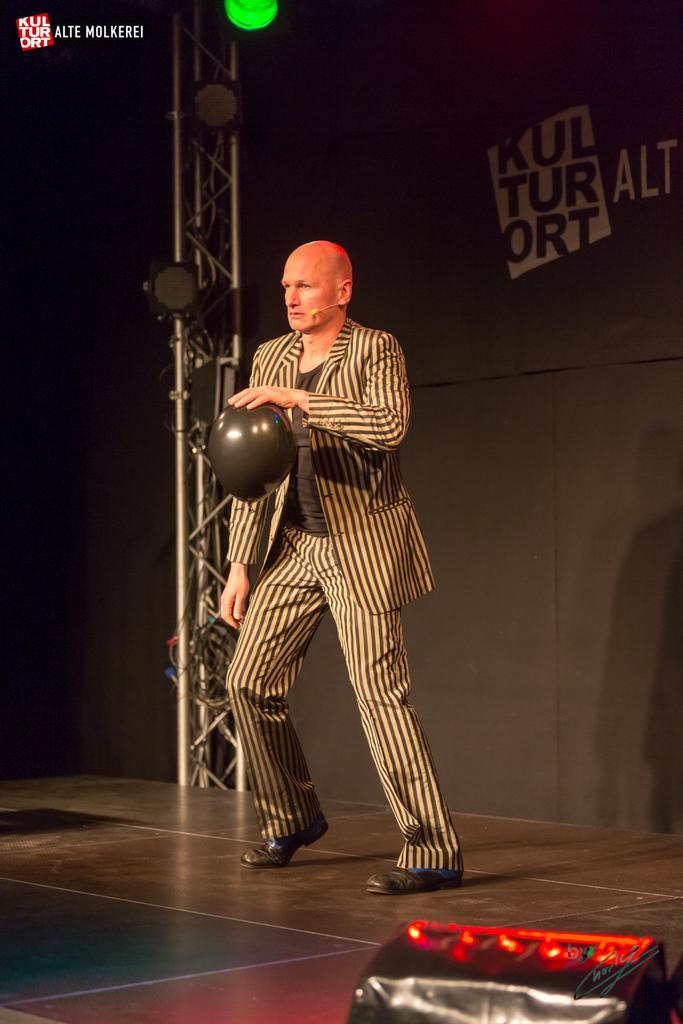Can you describe this image briefly? In this picture there is a man who is standing on the stage and holding a black balloon. Beside him I can see the pole and black color wall. On the pole I can see the speakers and focus light. On the top left corner there is a watermark. In the bottom right corner it might be the speaker. 